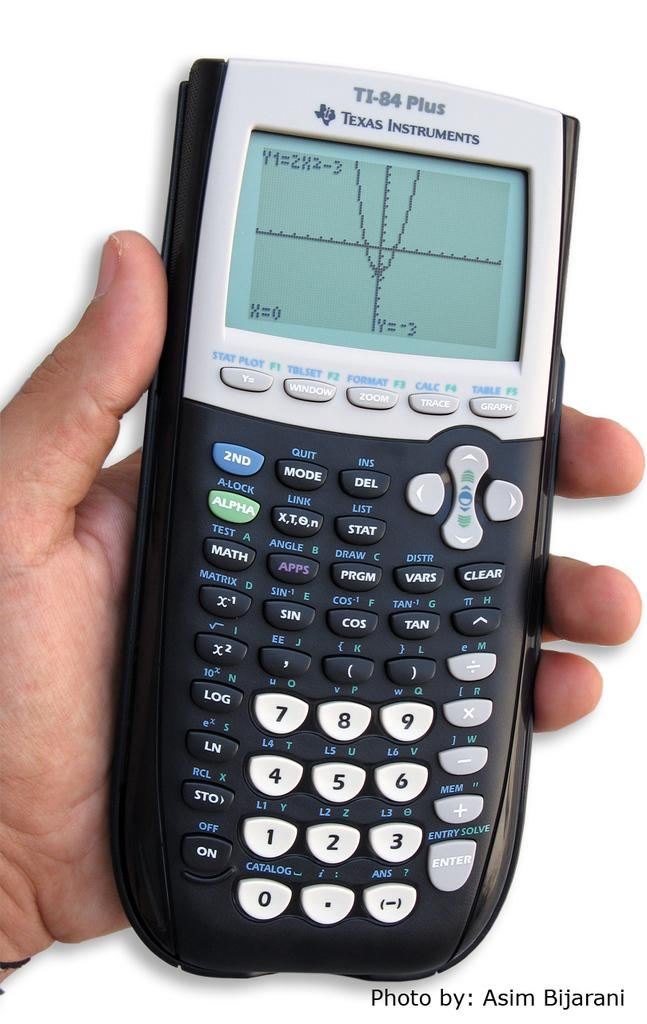<image>
Present a compact description of the photo's key features. TI-84 calculator shows a parabola on its screen. 